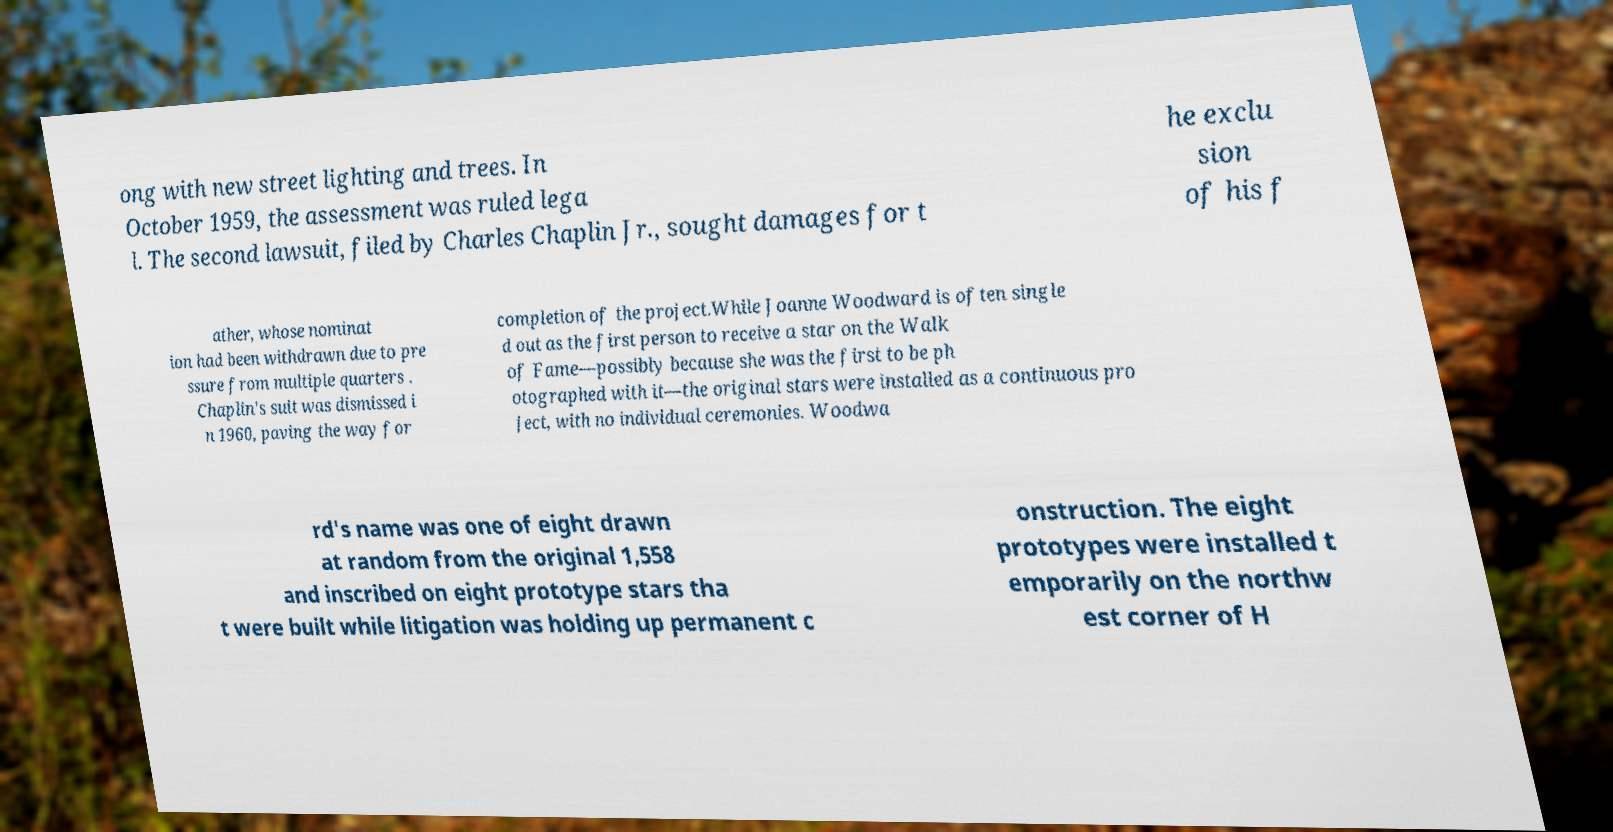Can you accurately transcribe the text from the provided image for me? ong with new street lighting and trees. In October 1959, the assessment was ruled lega l. The second lawsuit, filed by Charles Chaplin Jr., sought damages for t he exclu sion of his f ather, whose nominat ion had been withdrawn due to pre ssure from multiple quarters . Chaplin's suit was dismissed i n 1960, paving the way for completion of the project.While Joanne Woodward is often single d out as the first person to receive a star on the Walk of Fame—possibly because she was the first to be ph otographed with it—the original stars were installed as a continuous pro ject, with no individual ceremonies. Woodwa rd's name was one of eight drawn at random from the original 1,558 and inscribed on eight prototype stars tha t were built while litigation was holding up permanent c onstruction. The eight prototypes were installed t emporarily on the northw est corner of H 